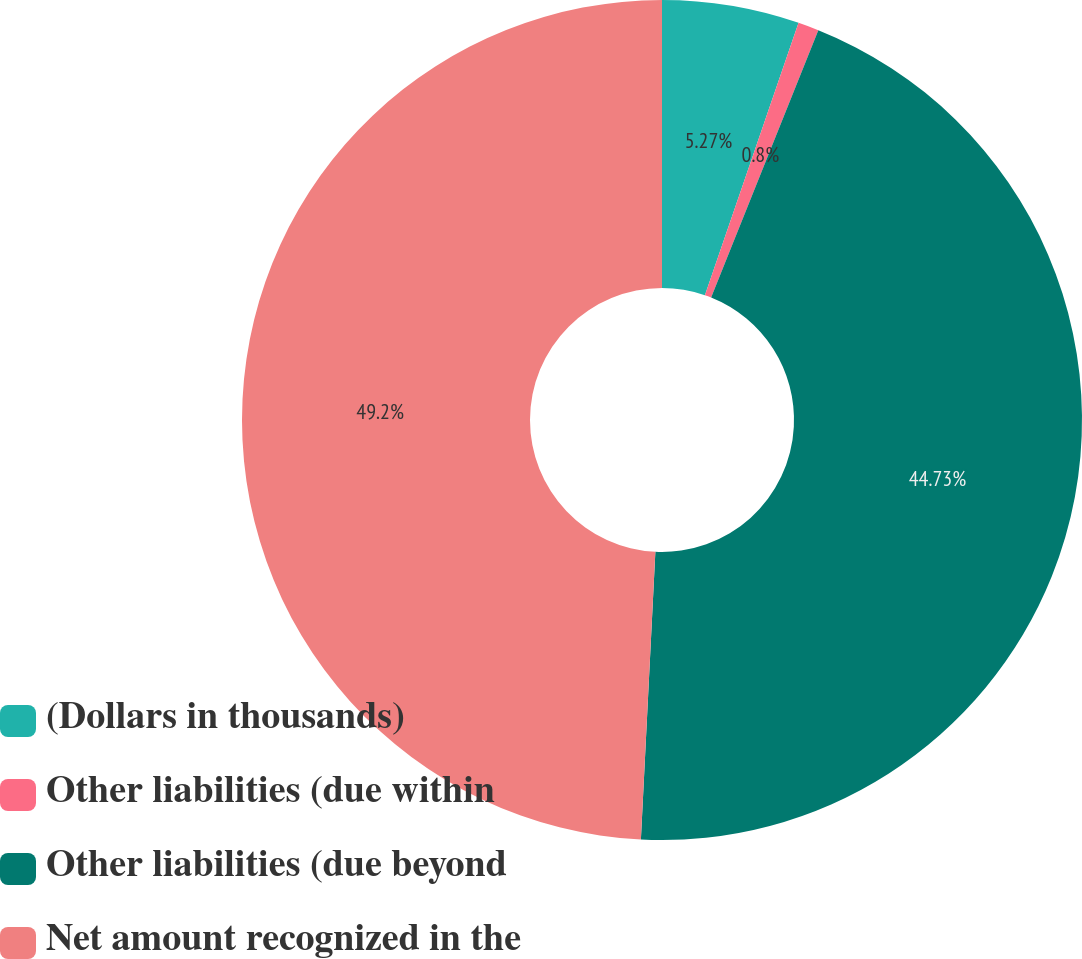Convert chart to OTSL. <chart><loc_0><loc_0><loc_500><loc_500><pie_chart><fcel>(Dollars in thousands)<fcel>Other liabilities (due within<fcel>Other liabilities (due beyond<fcel>Net amount recognized in the<nl><fcel>5.27%<fcel>0.8%<fcel>44.73%<fcel>49.2%<nl></chart> 